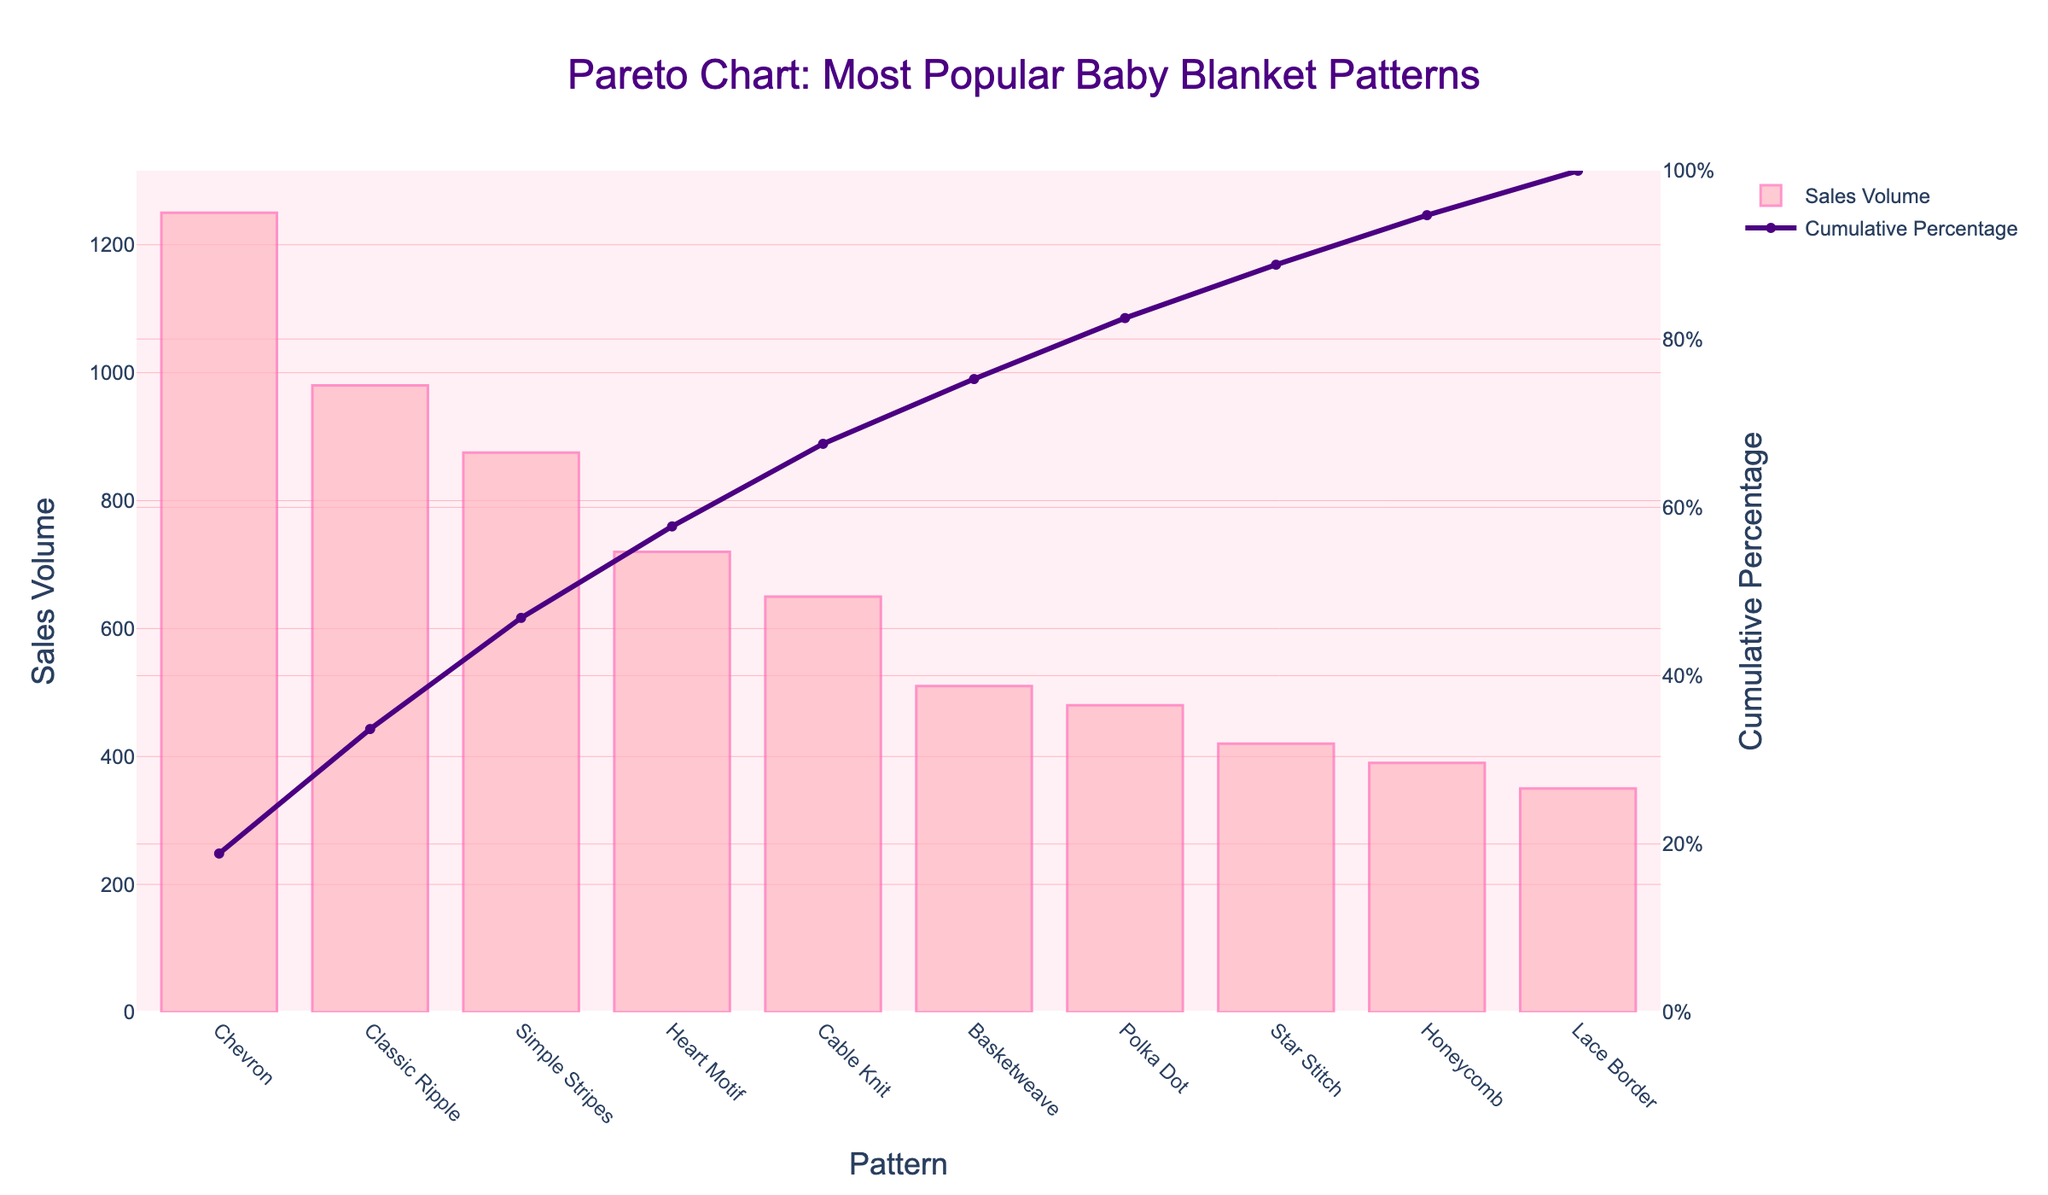What is the title of the Pareto chart? The title is found at the top of the chart and it summarizes what the chart is about.
Answer: Pareto Chart: Most Popular Baby Blanket Patterns Which baby blanket pattern has the highest sales volume? The bar with the greatest height represents the pattern with the highest sales volume.
Answer: Chevron What is the cumulative percentage for the Classic Ripple pattern? Look at the line chart for the Classic Ripple pattern to find its cumulative percentage value on the right y-axis.
Answer: 40.61% Which pattern has a higher sales volume, Heart Motif or Lace Border? Compare the heights of the bars for the Heart Motif and Lace Border patterns.
Answer: Heart Motif How many blanket patterns have a cumulative percentage of less than 50%? Count the data points on the line chart where the cumulative percentage is less than 50%.
Answer: 3 What is the difference in sales volume between the Simple Stripes and Honeycomb patterns? Subtract the sales volume of the Honeycomb from the sales volume of the Simple Stripes.
Answer: 485 Which pattern ranks third in sales volume? Look for the third highest bar in the chart.
Answer: Simple Stripes What percentage of the total sales volume is contributed by the top two patterns? Sum the sales volume of the top two patterns, then divide by the total sales volume, and multiply by 100.
Answer: 53.76% Which pattern has the lowest sales volume, and what is its cumulative percentage? Identify the pattern with the smallest bar and then look at its corresponding value on the cumulative percentage line.
Answer: Lace Border, 94.65% Is the sales volume of the Cable Knit pattern greater or less than the average sales volume of all patterns? First, calculate the average sales volume by adding all sales volumes and dividing by the number of patterns. Then, compare this average to the Cable Knit sales volume.
Answer: Greater 